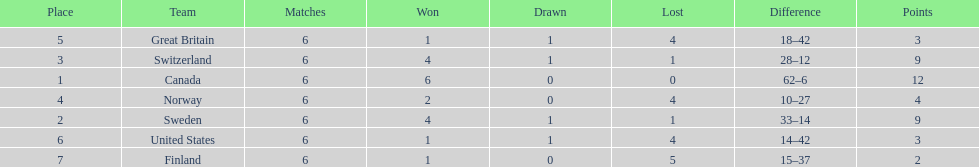How many teams won 6 matches? 1. 